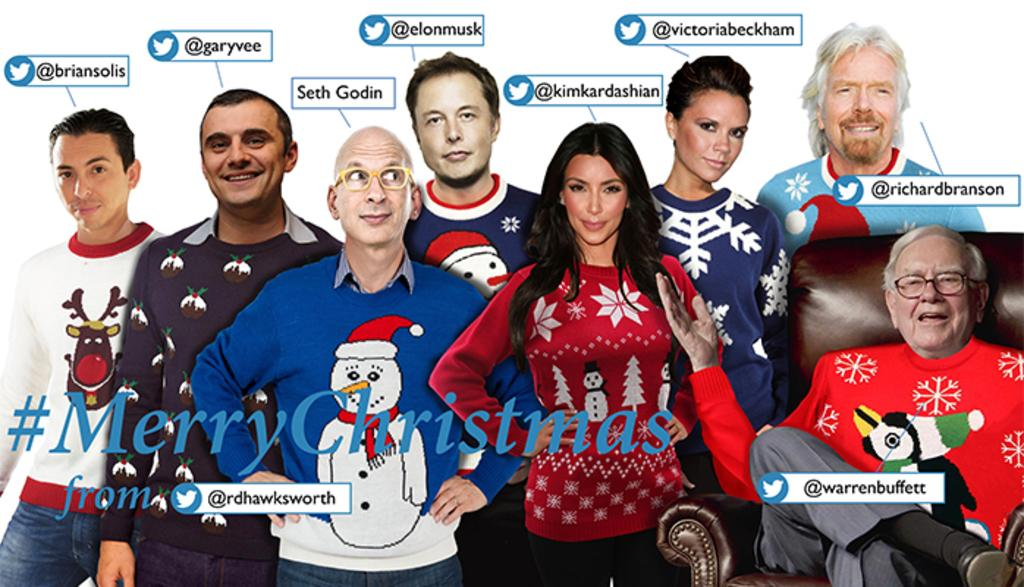<image>
Present a compact description of the photo's key features. many celebrities with one that has victoria beckham on it 